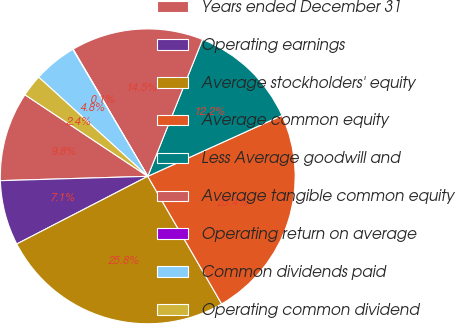Convert chart. <chart><loc_0><loc_0><loc_500><loc_500><pie_chart><fcel>Years ended December 31<fcel>Operating earnings<fcel>Average stockholders' equity<fcel>Average common equity<fcel>Less Average goodwill and<fcel>Average tangible common equity<fcel>Operating return on average<fcel>Common dividends paid<fcel>Operating common dividend<nl><fcel>9.8%<fcel>7.12%<fcel>25.77%<fcel>23.42%<fcel>12.16%<fcel>14.51%<fcel>0.05%<fcel>4.76%<fcel>2.41%<nl></chart> 